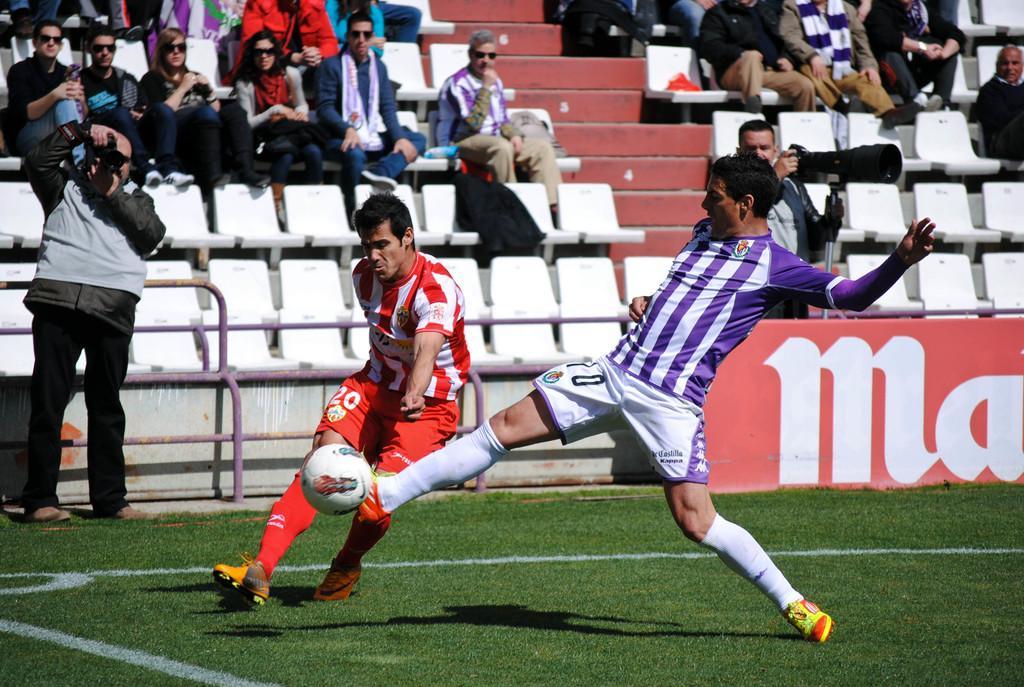Can you describe this image briefly? In this picture there are two football players playing with the ball. In the background spectators looking at them. At the left side there is a cameraman shooting the football players 